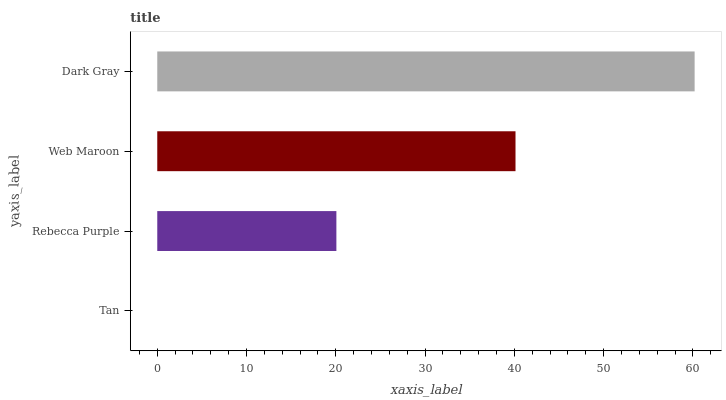Is Tan the minimum?
Answer yes or no. Yes. Is Dark Gray the maximum?
Answer yes or no. Yes. Is Rebecca Purple the minimum?
Answer yes or no. No. Is Rebecca Purple the maximum?
Answer yes or no. No. Is Rebecca Purple greater than Tan?
Answer yes or no. Yes. Is Tan less than Rebecca Purple?
Answer yes or no. Yes. Is Tan greater than Rebecca Purple?
Answer yes or no. No. Is Rebecca Purple less than Tan?
Answer yes or no. No. Is Web Maroon the high median?
Answer yes or no. Yes. Is Rebecca Purple the low median?
Answer yes or no. Yes. Is Rebecca Purple the high median?
Answer yes or no. No. Is Dark Gray the low median?
Answer yes or no. No. 